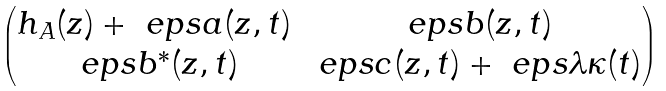<formula> <loc_0><loc_0><loc_500><loc_500>\begin{pmatrix} h _ { A } ( z ) + \ e p s a ( z , t ) & \ e p s b ( z , t ) \\ \ e p s b ^ { * } ( z , t ) & \ e p s c ( z , t ) + \ e p s \lambda \kappa ( t ) \end{pmatrix}</formula> 